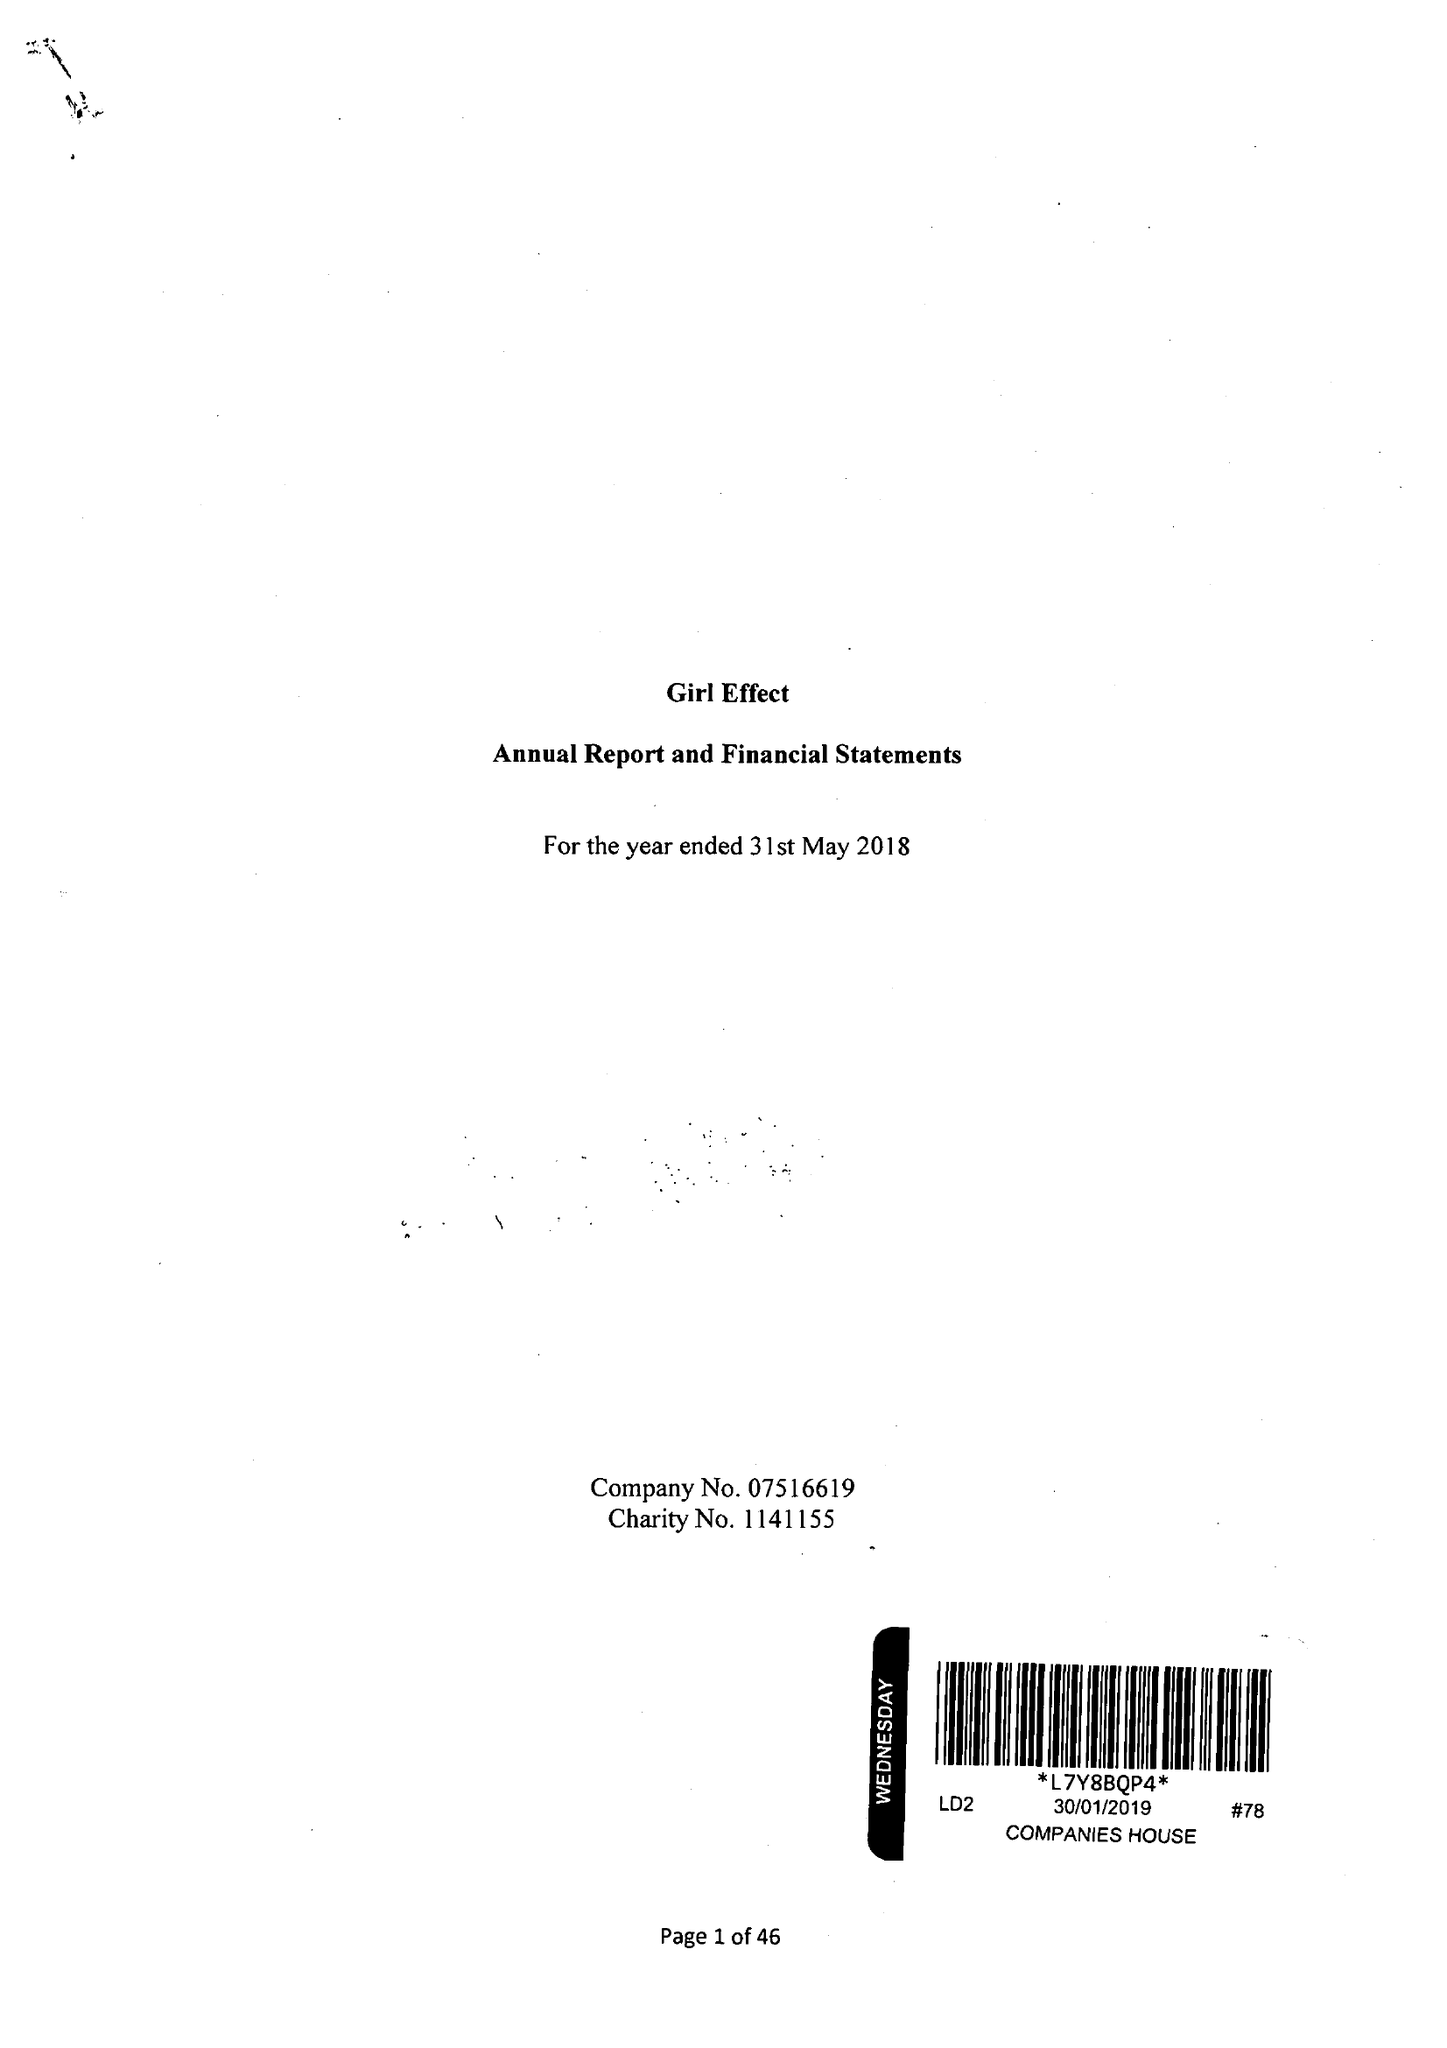What is the value for the spending_annually_in_british_pounds?
Answer the question using a single word or phrase. 25918568.00 